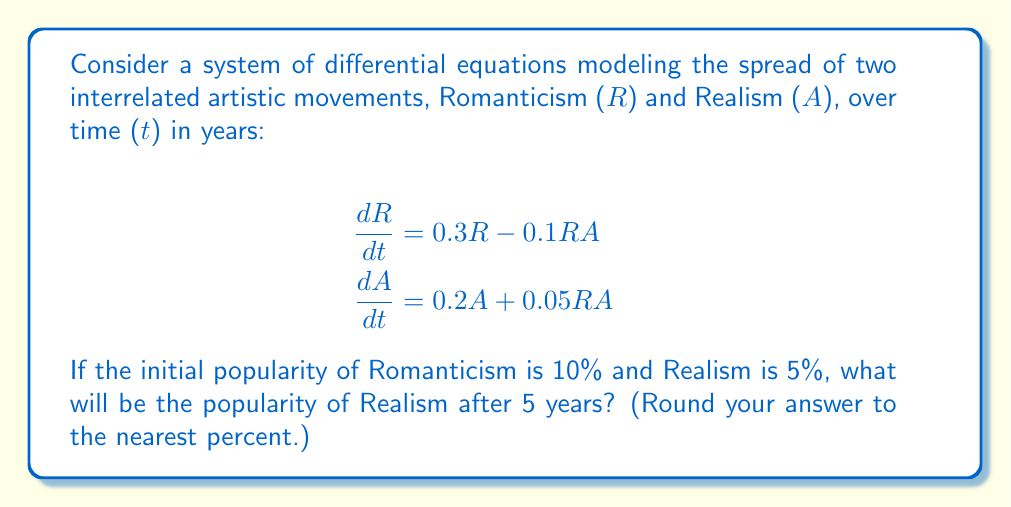Provide a solution to this math problem. To solve this system of differential equations, we'll use numerical methods, specifically the Runge-Kutta 4th order method (RK4). This method is well-suited for solving systems of ODEs with good accuracy.

Let's define our initial conditions:
$R(0) = 0.1$ (10% initial popularity for Romanticism)
$A(0) = 0.05$ (5% initial popularity for Realism)

The RK4 method for a system of two ODEs is given by:

For $i = 1, 2, ..., n$:
$$R_{i+1} = R_i + \frac{1}{6}(k_{1R} + 2k_{2R} + 2k_{3R} + k_{4R})$$
$$A_{i+1} = A_i + \frac{1}{6}(k_{1A} + 2k_{2A} + 2k_{3A} + k_{4A})$$

Where:
$$k_{1R} = h f_R(t_i, R_i, A_i)$$
$$k_{1A} = h f_A(t_i, R_i, A_i)$$
$$k_{2R} = h f_R(t_i + \frac{h}{2}, R_i + \frac{k_{1R}}{2}, A_i + \frac{k_{1A}}{2})$$
$$k_{2A} = h f_A(t_i + \frac{h}{2}, R_i + \frac{k_{1R}}{2}, A_i + \frac{k_{1A}}{2})$$
$$k_{3R} = h f_R(t_i + \frac{h}{2}, R_i + \frac{k_{2R}}{2}, A_i + \frac{k_{2A}}{2})$$
$$k_{3A} = h f_A(t_i + \frac{h}{2}, R_i + \frac{k_{2R}}{2}, A_i + \frac{k_{2A}}{2})$$
$$k_{4R} = h f_R(t_i + h, R_i + k_{3R}, A_i + k_{3A})$$
$$k_{4A} = h f_A(t_i + h, R_i + k_{3R}, A_i + k_{3A})$$

Here, $h$ is the step size. We'll use $h = 0.1$ for good accuracy, which means we'll perform 50 iterations to reach $t = 5$.

$f_R(t, R, A) = 0.3R - 0.1RA$
$f_A(t, R, A) = 0.2A + 0.05RA$

Implementing this method (which would typically be done using a computer program), we get the following results after 5 years:

$R(5) \approx 0.2997$
$A(5) \approx 0.1641$

Therefore, the popularity of Realism after 5 years is approximately 16.41%.
Answer: 16% 